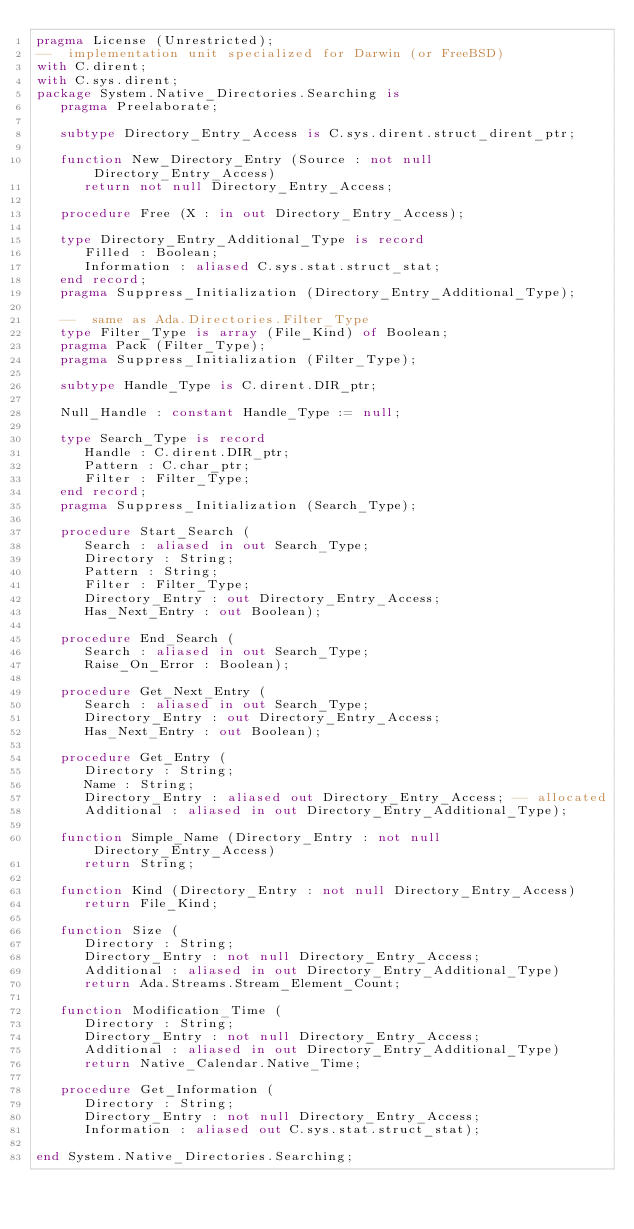Convert code to text. <code><loc_0><loc_0><loc_500><loc_500><_Ada_>pragma License (Unrestricted);
--  implementation unit specialized for Darwin (or FreeBSD)
with C.dirent;
with C.sys.dirent;
package System.Native_Directories.Searching is
   pragma Preelaborate;

   subtype Directory_Entry_Access is C.sys.dirent.struct_dirent_ptr;

   function New_Directory_Entry (Source : not null Directory_Entry_Access)
      return not null Directory_Entry_Access;

   procedure Free (X : in out Directory_Entry_Access);

   type Directory_Entry_Additional_Type is record
      Filled : Boolean;
      Information : aliased C.sys.stat.struct_stat;
   end record;
   pragma Suppress_Initialization (Directory_Entry_Additional_Type);

   --  same as Ada.Directories.Filter_Type
   type Filter_Type is array (File_Kind) of Boolean;
   pragma Pack (Filter_Type);
   pragma Suppress_Initialization (Filter_Type);

   subtype Handle_Type is C.dirent.DIR_ptr;

   Null_Handle : constant Handle_Type := null;

   type Search_Type is record
      Handle : C.dirent.DIR_ptr;
      Pattern : C.char_ptr;
      Filter : Filter_Type;
   end record;
   pragma Suppress_Initialization (Search_Type);

   procedure Start_Search (
      Search : aliased in out Search_Type;
      Directory : String;
      Pattern : String;
      Filter : Filter_Type;
      Directory_Entry : out Directory_Entry_Access;
      Has_Next_Entry : out Boolean);

   procedure End_Search (
      Search : aliased in out Search_Type;
      Raise_On_Error : Boolean);

   procedure Get_Next_Entry (
      Search : aliased in out Search_Type;
      Directory_Entry : out Directory_Entry_Access;
      Has_Next_Entry : out Boolean);

   procedure Get_Entry (
      Directory : String;
      Name : String;
      Directory_Entry : aliased out Directory_Entry_Access; -- allocated
      Additional : aliased in out Directory_Entry_Additional_Type);

   function Simple_Name (Directory_Entry : not null Directory_Entry_Access)
      return String;

   function Kind (Directory_Entry : not null Directory_Entry_Access)
      return File_Kind;

   function Size (
      Directory : String;
      Directory_Entry : not null Directory_Entry_Access;
      Additional : aliased in out Directory_Entry_Additional_Type)
      return Ada.Streams.Stream_Element_Count;

   function Modification_Time (
      Directory : String;
      Directory_Entry : not null Directory_Entry_Access;
      Additional : aliased in out Directory_Entry_Additional_Type)
      return Native_Calendar.Native_Time;

   procedure Get_Information (
      Directory : String;
      Directory_Entry : not null Directory_Entry_Access;
      Information : aliased out C.sys.stat.struct_stat);

end System.Native_Directories.Searching;
</code> 